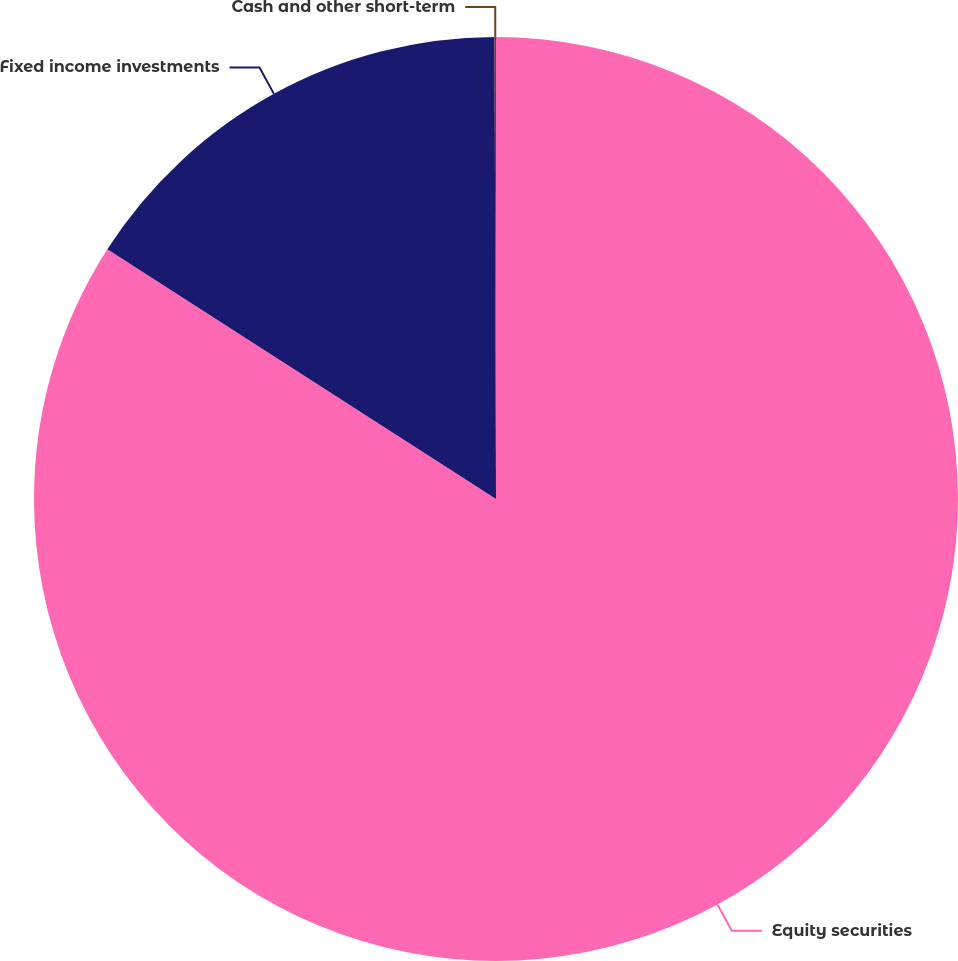<chart> <loc_0><loc_0><loc_500><loc_500><pie_chart><fcel>Equity securities<fcel>Fixed income investments<fcel>Cash and other short-term<nl><fcel>84.09%<fcel>15.86%<fcel>0.05%<nl></chart> 